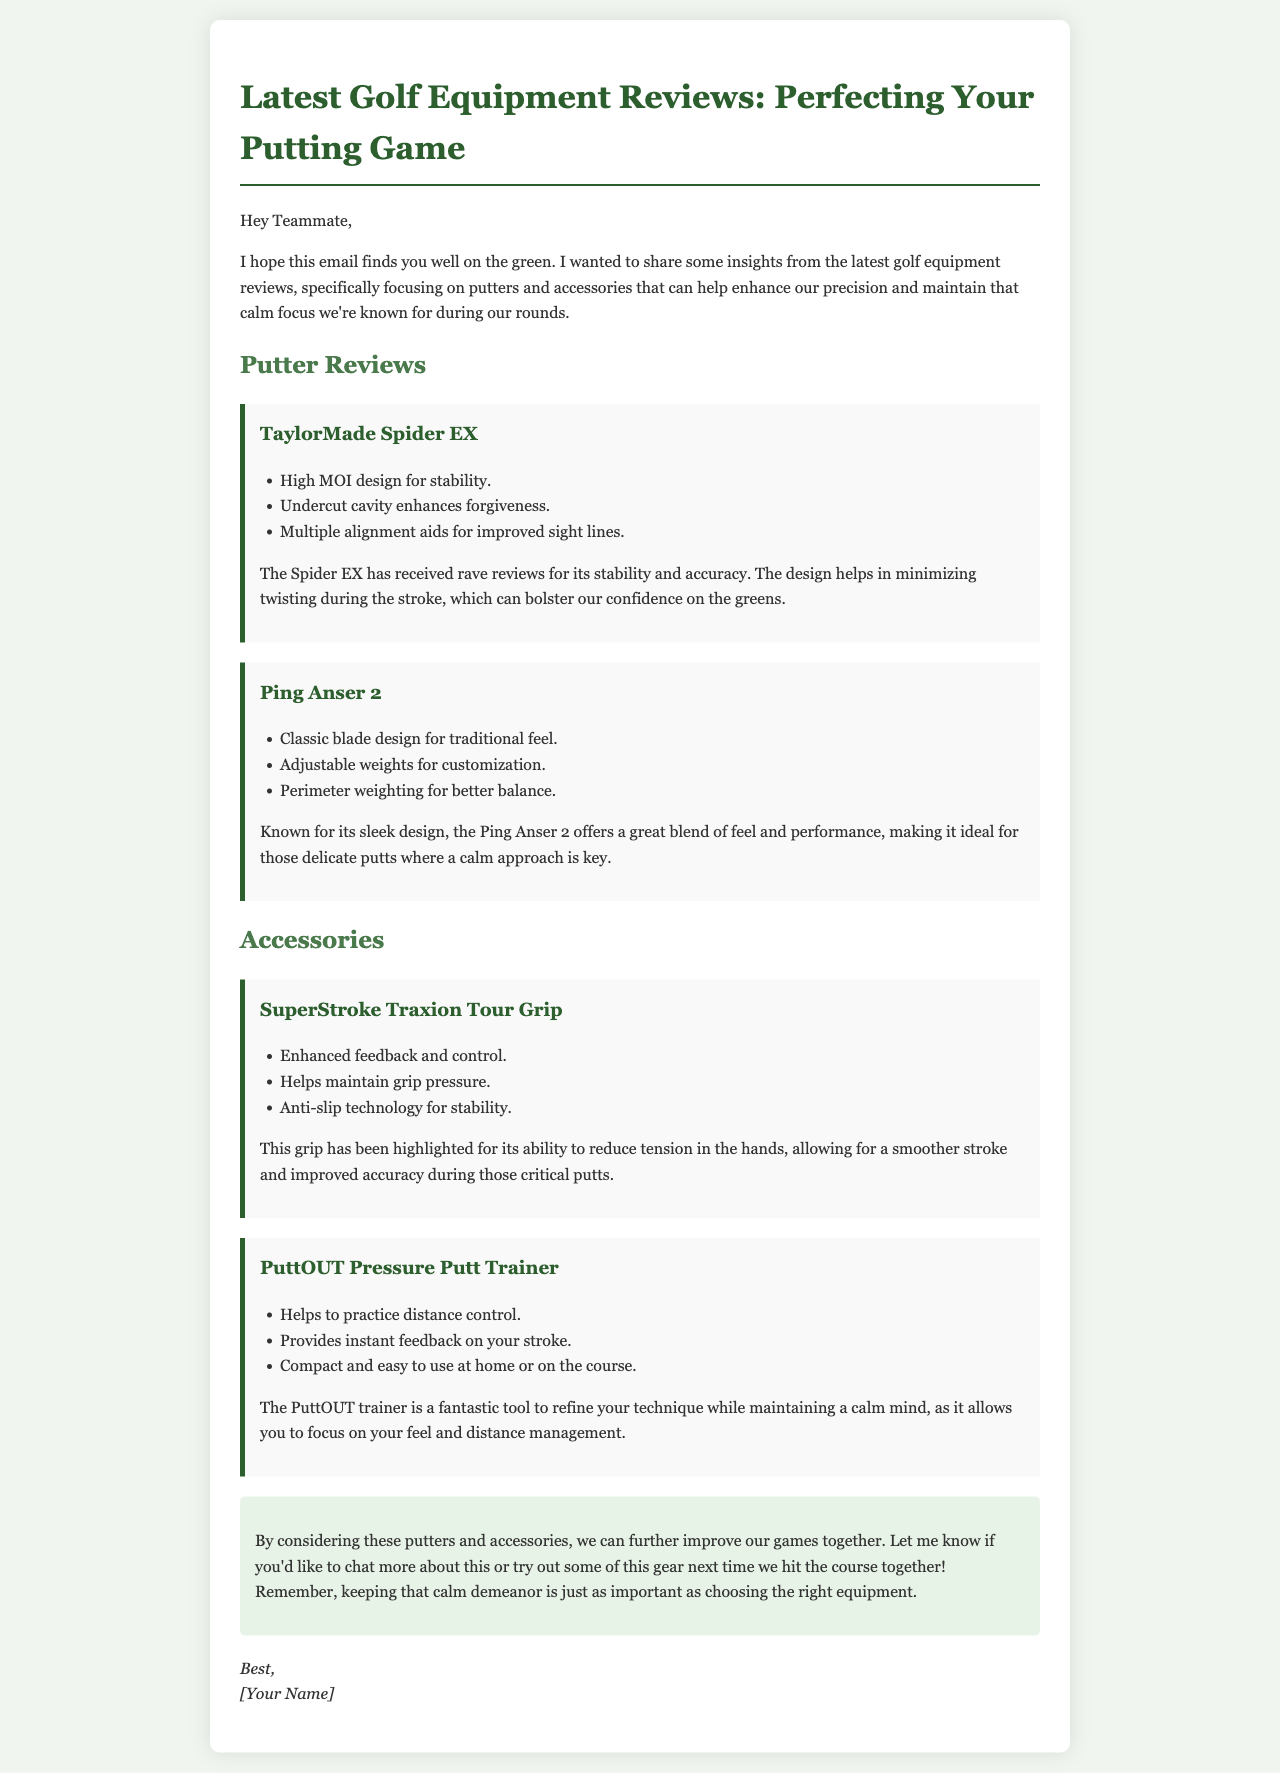What is the title of the document? The title of the document is stated in the `<title>` tag of the HTML code.
Answer: Latest Golf Equipment Reviews: Perfecting Your Putting Game Who is the email addressed to? The email begins with the greeting "Hey Teammate," which indicates the recipient is a teammate.
Answer: Teammate What accessory helps maintain grip pressure? The information is found in the review of the SuperStroke Traxion Tour Grip, which mentions grip pressure explicitly.
Answer: SuperStroke Traxion Tour Grip How many putters are reviewed in the document? The document lists two putters under the "Putter Reviews" section.
Answer: Two What feature of the TaylorMade Spider EX enhances stability? The document mentions "High MOI design for stability" in the review of the TaylorMade Spider EX.
Answer: High MOI design Which item provides instant feedback on your stroke? The information is found in the review of the PuttOUT Pressure Putt Trainer, which states it provides instant feedback.
Answer: PuttOUT Pressure Putt Trainer What is the main benefit of the PuttOUT trainer? Based on the review, the primary benefit is practicing distance control while maintaining a calm mind.
Answer: Practice distance control What is the significance of "calm focus" in the email? The term "calm focus" is emphasized multiple times, highlighting its importance for maintaining composure during putting.
Answer: Important for composure Who signed off the email? The sign-off of the email is indicated at the bottom with "[Your Name]," which represents the sender.
Answer: [Your Name] 